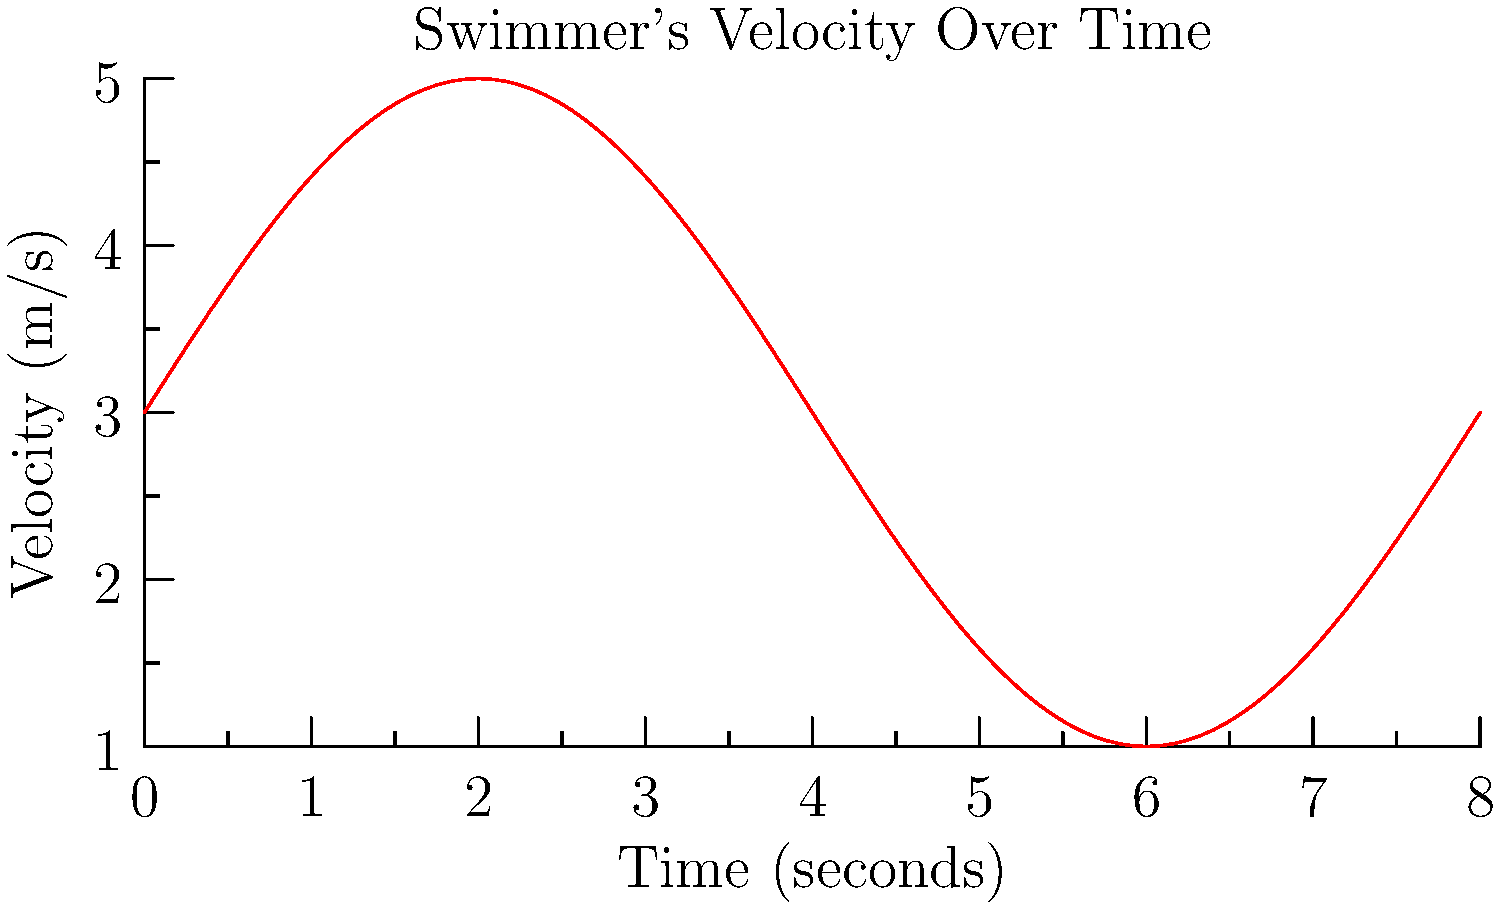The graph shows a swimmer's velocity over time. What is the total distance traveled by the swimmer during the 8-second interval? To find the total distance traveled, we need to calculate the area under the velocity-time curve. This can be done using integration.

1. The velocity function is given by $v(t) = 2\sin(\frac{\pi t}{4}) + 3$.

2. The distance traveled is the integral of velocity over time:
   $$ d = \int_0^8 v(t) \, dt = \int_0^8 (2\sin(\frac{\pi t}{4}) + 3) \, dt $$

3. Integrate the function:
   $$ d = [-\frac{8}{\pi}\cos(\frac{\pi t}{4}) + 3t]_0^8 $$

4. Evaluate the integral:
   $$ d = [-\frac{8}{\pi}\cos(2\pi) + 3(8)] - [-\frac{8}{\pi}\cos(0) + 3(0)] $$
   $$ d = [-\frac{8}{\pi} + 24] - [-\frac{8}{\pi}] $$
   $$ d = 24 $$

5. The total distance traveled is 24 meters.
Answer: 24 meters 